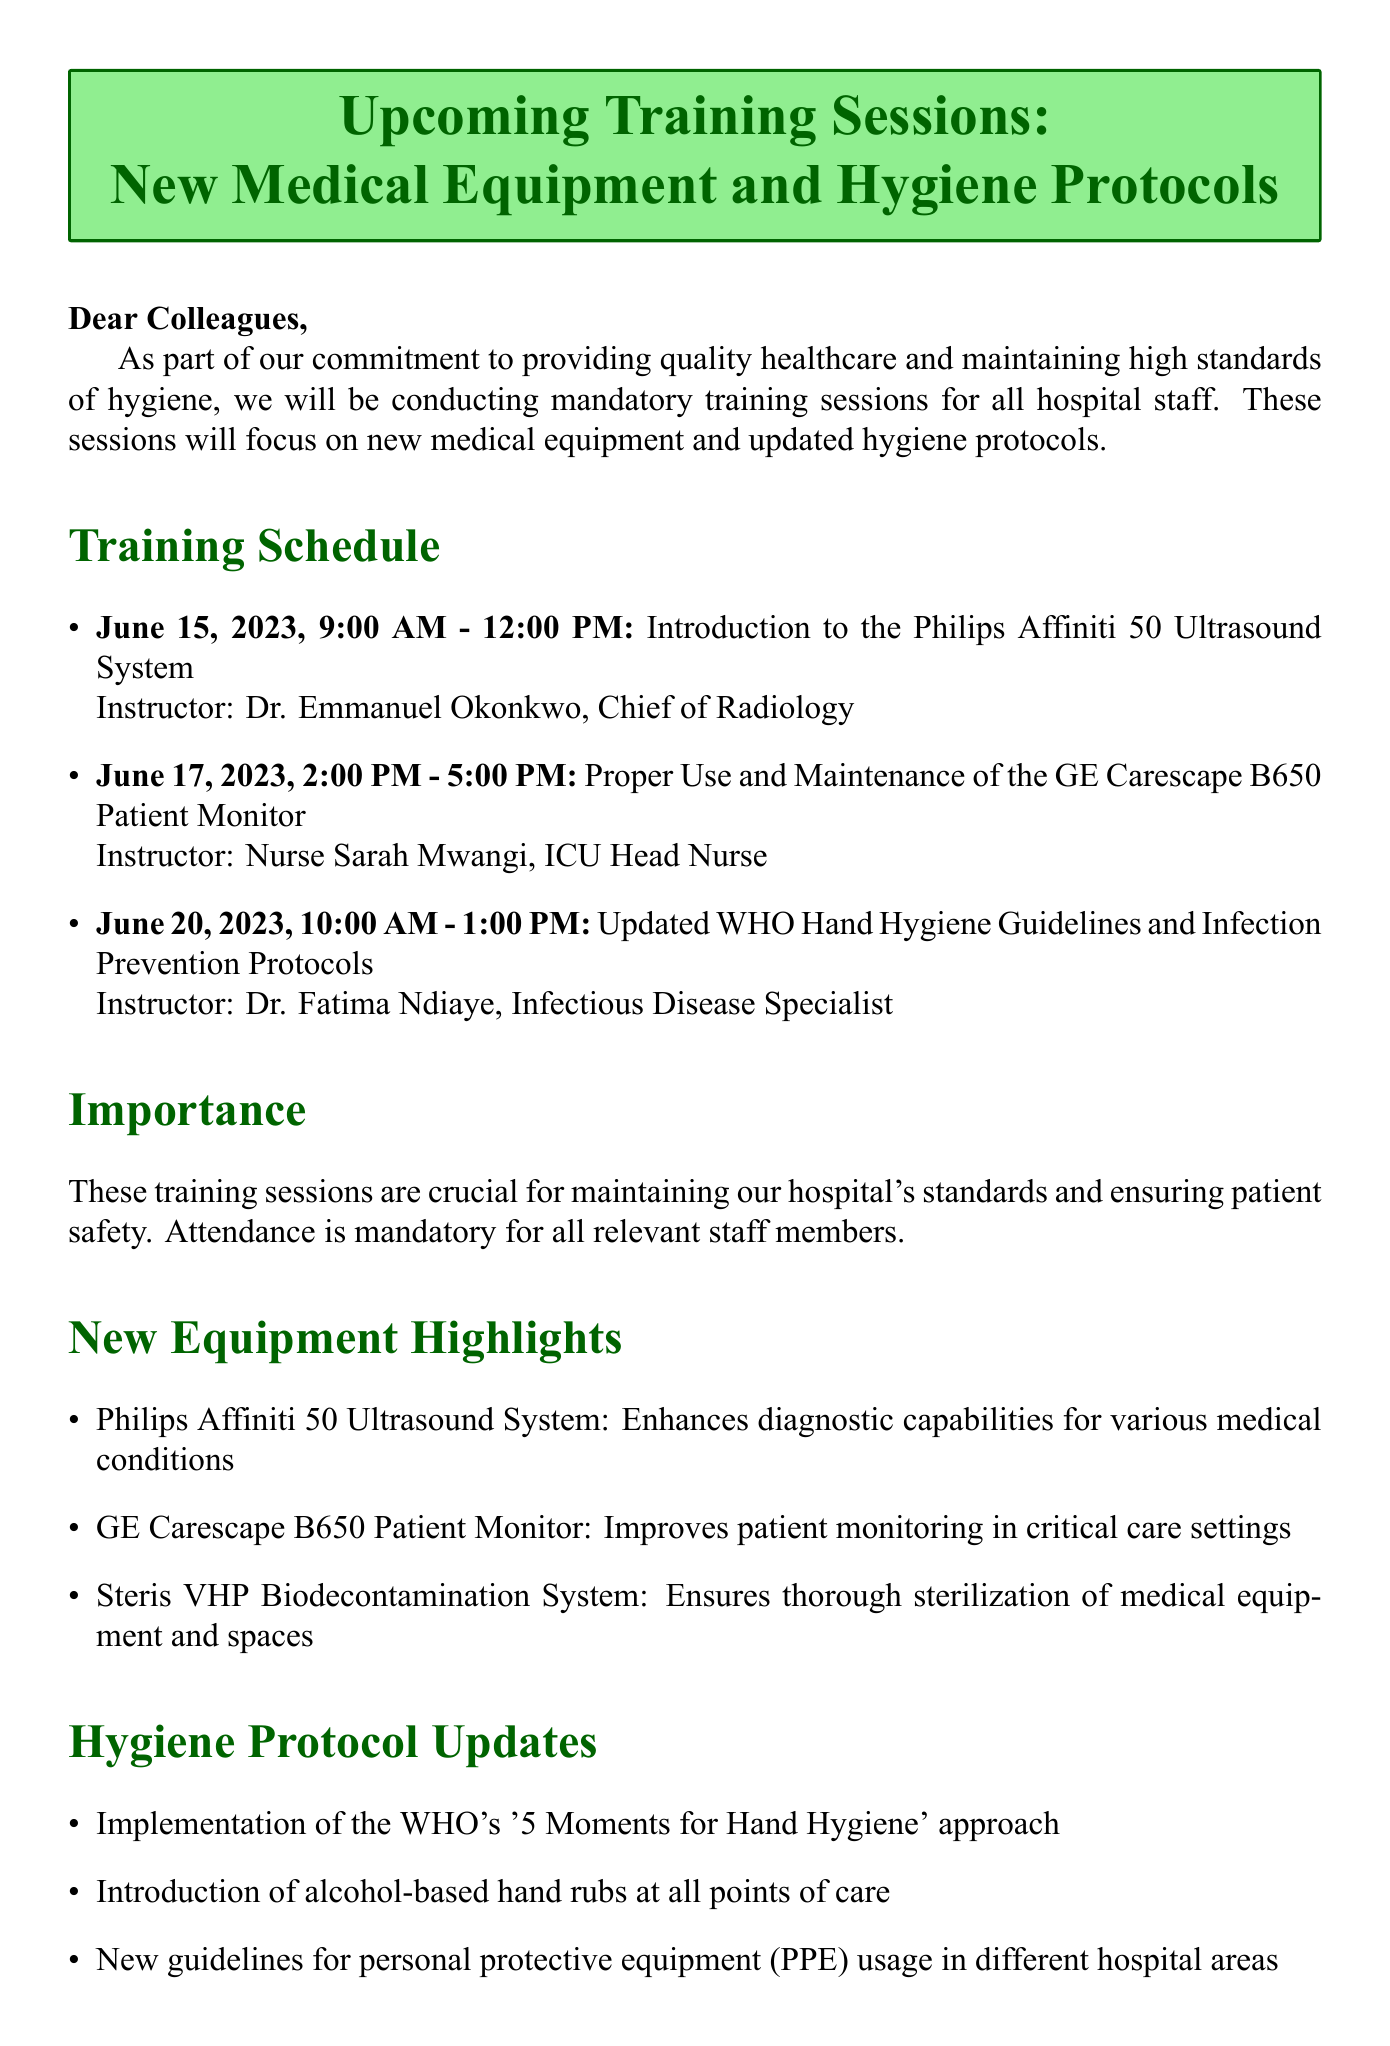What is the date of the first training session? The date of the first training session is clearly stated in the training schedule as June 15, 2023.
Answer: June 15, 2023 Who is the instructor for the second training session? The instructor for the second training session on June 17, 2023, is mentioned as Nurse Sarah Mwangi.
Answer: Nurse Sarah Mwangi What is the topic of the training on June 20, 2023? The topic for the training session on June 20, 2023, is specified as Updated WHO Hand Hygiene Guidelines and Infection Prevention Protocols.
Answer: Updated WHO Hand Hygiene Guidelines and Infection Prevention Protocols What medical equipment is highlighted for use in critical care settings? The document highlights the GE Carescape B650 Patient Monitor as important for improving patient monitoring in critical care settings.
Answer: GE Carescape B650 Patient Monitor What new hygiene guideline is mentioned in the document? The document mentions the implementation of the WHO's '5 Moments for Hand Hygiene' approach as a new hygiene guideline.
Answer: WHO's '5 Moments for Hand Hygiene' Why are these training sessions considered important? It states that the training sessions are crucial for maintaining the hospital's standards and ensuring patient safety, highlighting their significance.
Answer: Patient safety What is the primary focus of the training sessions? The primary focus of the training sessions is on new medical equipment and updated hygiene protocols for hospital staff.
Answer: New medical equipment and updated hygiene protocols Which instructor is responsible for training on the Philips Affiniti 50 Ultrasound System? The document specifies that Dr. Emmanuel Okonkwo, Chief of Radiology, is the instructor for the training on the Philips Affiniti 50 Ultrasound System.
Answer: Dr. Emmanuel Okonkwo What unique challenges do healthcare providers in sub-Saharan Africa face? The document indicates that healthcare providers in sub-Saharan Africa face unique challenges such as adapting hygiene protocols to limited water resources.
Answer: Limited water resources 